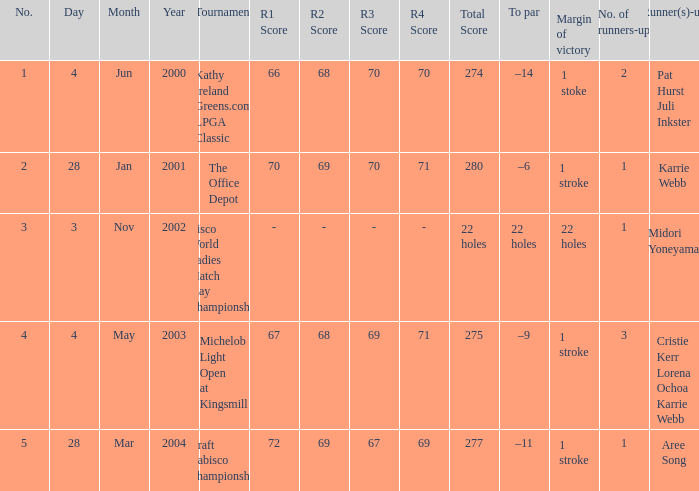Where is the margin of victory dated mar 28, 2004? 1 stroke. 